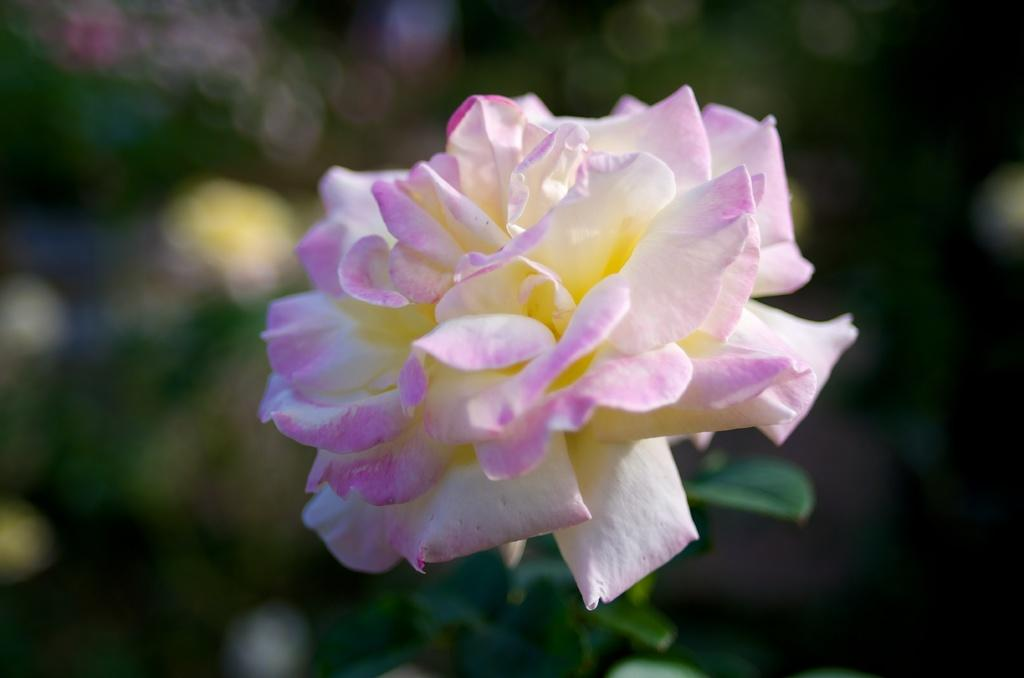What type of flower is in the image? There is a rose in the image. What colors can be seen on the rose? The rose is white and pink in color. What color is the background of the flower? The background of the flower is blue. What type of soap is being used to clean the bottle in the image? There is no bottle or soap present in the image; it features a rose with a blue background. 